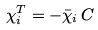<formula> <loc_0><loc_0><loc_500><loc_500>\chi _ { i } ^ { T } = - \bar { \chi } _ { i } \, C</formula> 